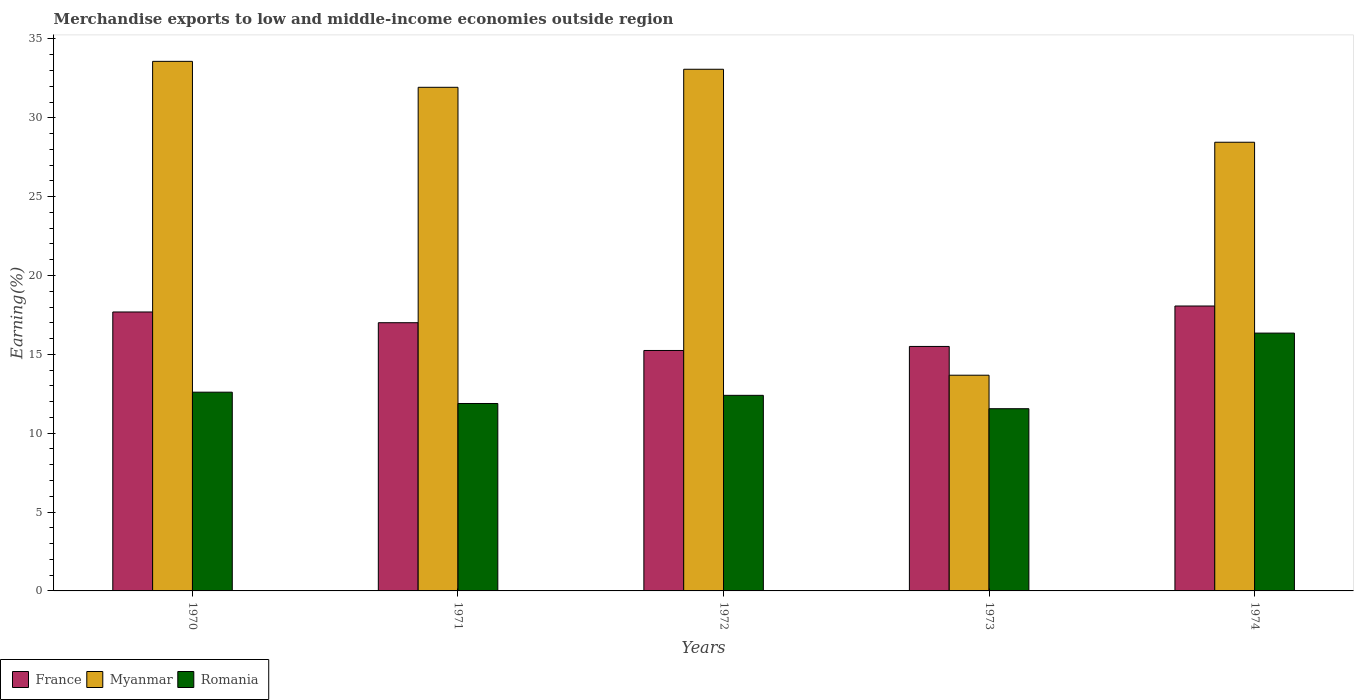How many different coloured bars are there?
Offer a very short reply. 3. How many groups of bars are there?
Provide a short and direct response. 5. Are the number of bars per tick equal to the number of legend labels?
Your answer should be very brief. Yes. How many bars are there on the 4th tick from the left?
Offer a terse response. 3. What is the percentage of amount earned from merchandise exports in France in 1973?
Give a very brief answer. 15.5. Across all years, what is the maximum percentage of amount earned from merchandise exports in Romania?
Your answer should be compact. 16.35. Across all years, what is the minimum percentage of amount earned from merchandise exports in Myanmar?
Provide a succinct answer. 13.68. In which year was the percentage of amount earned from merchandise exports in Myanmar maximum?
Ensure brevity in your answer.  1970. What is the total percentage of amount earned from merchandise exports in France in the graph?
Provide a short and direct response. 83.51. What is the difference between the percentage of amount earned from merchandise exports in France in 1972 and that in 1974?
Your response must be concise. -2.82. What is the difference between the percentage of amount earned from merchandise exports in Myanmar in 1970 and the percentage of amount earned from merchandise exports in Romania in 1971?
Offer a terse response. 21.7. What is the average percentage of amount earned from merchandise exports in Myanmar per year?
Make the answer very short. 28.15. In the year 1972, what is the difference between the percentage of amount earned from merchandise exports in France and percentage of amount earned from merchandise exports in Myanmar?
Your answer should be very brief. -17.83. In how many years, is the percentage of amount earned from merchandise exports in Romania greater than 2 %?
Your answer should be compact. 5. What is the ratio of the percentage of amount earned from merchandise exports in France in 1971 to that in 1972?
Make the answer very short. 1.12. Is the difference between the percentage of amount earned from merchandise exports in France in 1971 and 1972 greater than the difference between the percentage of amount earned from merchandise exports in Myanmar in 1971 and 1972?
Give a very brief answer. Yes. What is the difference between the highest and the second highest percentage of amount earned from merchandise exports in Romania?
Provide a short and direct response. 3.75. What is the difference between the highest and the lowest percentage of amount earned from merchandise exports in Romania?
Give a very brief answer. 4.79. Is the sum of the percentage of amount earned from merchandise exports in Romania in 1971 and 1973 greater than the maximum percentage of amount earned from merchandise exports in France across all years?
Ensure brevity in your answer.  Yes. What does the 3rd bar from the left in 1971 represents?
Offer a terse response. Romania. What does the 1st bar from the right in 1972 represents?
Your response must be concise. Romania. Is it the case that in every year, the sum of the percentage of amount earned from merchandise exports in France and percentage of amount earned from merchandise exports in Romania is greater than the percentage of amount earned from merchandise exports in Myanmar?
Provide a short and direct response. No. What is the difference between two consecutive major ticks on the Y-axis?
Give a very brief answer. 5. Are the values on the major ticks of Y-axis written in scientific E-notation?
Your answer should be very brief. No. How many legend labels are there?
Make the answer very short. 3. What is the title of the graph?
Your answer should be compact. Merchandise exports to low and middle-income economies outside region. Does "St. Lucia" appear as one of the legend labels in the graph?
Ensure brevity in your answer.  No. What is the label or title of the Y-axis?
Make the answer very short. Earning(%). What is the Earning(%) in France in 1970?
Your answer should be compact. 17.69. What is the Earning(%) of Myanmar in 1970?
Provide a succinct answer. 33.58. What is the Earning(%) in Romania in 1970?
Offer a terse response. 12.6. What is the Earning(%) in France in 1971?
Offer a terse response. 17.01. What is the Earning(%) of Myanmar in 1971?
Offer a very short reply. 31.94. What is the Earning(%) in Romania in 1971?
Your answer should be very brief. 11.89. What is the Earning(%) in France in 1972?
Keep it short and to the point. 15.25. What is the Earning(%) in Myanmar in 1972?
Provide a succinct answer. 33.08. What is the Earning(%) of Romania in 1972?
Ensure brevity in your answer.  12.4. What is the Earning(%) of France in 1973?
Provide a succinct answer. 15.5. What is the Earning(%) of Myanmar in 1973?
Keep it short and to the point. 13.68. What is the Earning(%) of Romania in 1973?
Your answer should be compact. 11.55. What is the Earning(%) in France in 1974?
Provide a succinct answer. 18.07. What is the Earning(%) in Myanmar in 1974?
Make the answer very short. 28.45. What is the Earning(%) in Romania in 1974?
Your answer should be compact. 16.35. Across all years, what is the maximum Earning(%) of France?
Give a very brief answer. 18.07. Across all years, what is the maximum Earning(%) in Myanmar?
Offer a terse response. 33.58. Across all years, what is the maximum Earning(%) of Romania?
Give a very brief answer. 16.35. Across all years, what is the minimum Earning(%) in France?
Provide a short and direct response. 15.25. Across all years, what is the minimum Earning(%) in Myanmar?
Keep it short and to the point. 13.68. Across all years, what is the minimum Earning(%) in Romania?
Offer a terse response. 11.55. What is the total Earning(%) in France in the graph?
Offer a terse response. 83.51. What is the total Earning(%) of Myanmar in the graph?
Keep it short and to the point. 140.73. What is the total Earning(%) in Romania in the graph?
Your answer should be very brief. 64.79. What is the difference between the Earning(%) in France in 1970 and that in 1971?
Your answer should be compact. 0.68. What is the difference between the Earning(%) of Myanmar in 1970 and that in 1971?
Your answer should be very brief. 1.65. What is the difference between the Earning(%) of Romania in 1970 and that in 1971?
Offer a very short reply. 0.72. What is the difference between the Earning(%) in France in 1970 and that in 1972?
Provide a succinct answer. 2.44. What is the difference between the Earning(%) of Myanmar in 1970 and that in 1972?
Your response must be concise. 0.5. What is the difference between the Earning(%) in Romania in 1970 and that in 1972?
Keep it short and to the point. 0.2. What is the difference between the Earning(%) of France in 1970 and that in 1973?
Your answer should be compact. 2.19. What is the difference between the Earning(%) in Myanmar in 1970 and that in 1973?
Keep it short and to the point. 19.9. What is the difference between the Earning(%) of Romania in 1970 and that in 1973?
Your answer should be very brief. 1.05. What is the difference between the Earning(%) in France in 1970 and that in 1974?
Your response must be concise. -0.38. What is the difference between the Earning(%) of Myanmar in 1970 and that in 1974?
Make the answer very short. 5.13. What is the difference between the Earning(%) in Romania in 1970 and that in 1974?
Your answer should be compact. -3.75. What is the difference between the Earning(%) of France in 1971 and that in 1972?
Your answer should be very brief. 1.76. What is the difference between the Earning(%) of Myanmar in 1971 and that in 1972?
Your answer should be very brief. -1.14. What is the difference between the Earning(%) of Romania in 1971 and that in 1972?
Your answer should be compact. -0.52. What is the difference between the Earning(%) of France in 1971 and that in 1973?
Keep it short and to the point. 1.5. What is the difference between the Earning(%) in Myanmar in 1971 and that in 1973?
Make the answer very short. 18.26. What is the difference between the Earning(%) in Romania in 1971 and that in 1973?
Provide a short and direct response. 0.33. What is the difference between the Earning(%) in France in 1971 and that in 1974?
Make the answer very short. -1.06. What is the difference between the Earning(%) in Myanmar in 1971 and that in 1974?
Your response must be concise. 3.48. What is the difference between the Earning(%) of Romania in 1971 and that in 1974?
Offer a very short reply. -4.46. What is the difference between the Earning(%) of France in 1972 and that in 1973?
Keep it short and to the point. -0.26. What is the difference between the Earning(%) of Myanmar in 1972 and that in 1973?
Give a very brief answer. 19.4. What is the difference between the Earning(%) of Romania in 1972 and that in 1973?
Provide a short and direct response. 0.85. What is the difference between the Earning(%) in France in 1972 and that in 1974?
Offer a terse response. -2.82. What is the difference between the Earning(%) in Myanmar in 1972 and that in 1974?
Provide a succinct answer. 4.63. What is the difference between the Earning(%) of Romania in 1972 and that in 1974?
Keep it short and to the point. -3.95. What is the difference between the Earning(%) in France in 1973 and that in 1974?
Offer a terse response. -2.56. What is the difference between the Earning(%) of Myanmar in 1973 and that in 1974?
Offer a very short reply. -14.77. What is the difference between the Earning(%) in Romania in 1973 and that in 1974?
Keep it short and to the point. -4.79. What is the difference between the Earning(%) of France in 1970 and the Earning(%) of Myanmar in 1971?
Offer a terse response. -14.25. What is the difference between the Earning(%) of France in 1970 and the Earning(%) of Romania in 1971?
Give a very brief answer. 5.8. What is the difference between the Earning(%) of Myanmar in 1970 and the Earning(%) of Romania in 1971?
Provide a short and direct response. 21.7. What is the difference between the Earning(%) of France in 1970 and the Earning(%) of Myanmar in 1972?
Make the answer very short. -15.39. What is the difference between the Earning(%) in France in 1970 and the Earning(%) in Romania in 1972?
Ensure brevity in your answer.  5.29. What is the difference between the Earning(%) of Myanmar in 1970 and the Earning(%) of Romania in 1972?
Offer a terse response. 21.18. What is the difference between the Earning(%) of France in 1970 and the Earning(%) of Myanmar in 1973?
Give a very brief answer. 4.01. What is the difference between the Earning(%) of France in 1970 and the Earning(%) of Romania in 1973?
Ensure brevity in your answer.  6.13. What is the difference between the Earning(%) of Myanmar in 1970 and the Earning(%) of Romania in 1973?
Provide a short and direct response. 22.03. What is the difference between the Earning(%) in France in 1970 and the Earning(%) in Myanmar in 1974?
Your answer should be compact. -10.76. What is the difference between the Earning(%) of France in 1970 and the Earning(%) of Romania in 1974?
Ensure brevity in your answer.  1.34. What is the difference between the Earning(%) in Myanmar in 1970 and the Earning(%) in Romania in 1974?
Your response must be concise. 17.23. What is the difference between the Earning(%) of France in 1971 and the Earning(%) of Myanmar in 1972?
Ensure brevity in your answer.  -16.07. What is the difference between the Earning(%) of France in 1971 and the Earning(%) of Romania in 1972?
Offer a very short reply. 4.61. What is the difference between the Earning(%) in Myanmar in 1971 and the Earning(%) in Romania in 1972?
Give a very brief answer. 19.53. What is the difference between the Earning(%) of France in 1971 and the Earning(%) of Myanmar in 1973?
Provide a succinct answer. 3.33. What is the difference between the Earning(%) of France in 1971 and the Earning(%) of Romania in 1973?
Provide a succinct answer. 5.45. What is the difference between the Earning(%) in Myanmar in 1971 and the Earning(%) in Romania in 1973?
Provide a short and direct response. 20.38. What is the difference between the Earning(%) in France in 1971 and the Earning(%) in Myanmar in 1974?
Provide a succinct answer. -11.44. What is the difference between the Earning(%) of France in 1971 and the Earning(%) of Romania in 1974?
Keep it short and to the point. 0.66. What is the difference between the Earning(%) in Myanmar in 1971 and the Earning(%) in Romania in 1974?
Your response must be concise. 15.59. What is the difference between the Earning(%) of France in 1972 and the Earning(%) of Myanmar in 1973?
Provide a succinct answer. 1.57. What is the difference between the Earning(%) of France in 1972 and the Earning(%) of Romania in 1973?
Make the answer very short. 3.69. What is the difference between the Earning(%) of Myanmar in 1972 and the Earning(%) of Romania in 1973?
Keep it short and to the point. 21.53. What is the difference between the Earning(%) in France in 1972 and the Earning(%) in Myanmar in 1974?
Offer a terse response. -13.2. What is the difference between the Earning(%) in France in 1972 and the Earning(%) in Romania in 1974?
Offer a very short reply. -1.1. What is the difference between the Earning(%) of Myanmar in 1972 and the Earning(%) of Romania in 1974?
Offer a terse response. 16.73. What is the difference between the Earning(%) of France in 1973 and the Earning(%) of Myanmar in 1974?
Provide a succinct answer. -12.95. What is the difference between the Earning(%) of France in 1973 and the Earning(%) of Romania in 1974?
Provide a short and direct response. -0.85. What is the difference between the Earning(%) of Myanmar in 1973 and the Earning(%) of Romania in 1974?
Provide a short and direct response. -2.67. What is the average Earning(%) of France per year?
Provide a succinct answer. 16.7. What is the average Earning(%) of Myanmar per year?
Your response must be concise. 28.15. What is the average Earning(%) of Romania per year?
Ensure brevity in your answer.  12.96. In the year 1970, what is the difference between the Earning(%) in France and Earning(%) in Myanmar?
Ensure brevity in your answer.  -15.89. In the year 1970, what is the difference between the Earning(%) of France and Earning(%) of Romania?
Provide a short and direct response. 5.09. In the year 1970, what is the difference between the Earning(%) of Myanmar and Earning(%) of Romania?
Make the answer very short. 20.98. In the year 1971, what is the difference between the Earning(%) of France and Earning(%) of Myanmar?
Your answer should be very brief. -14.93. In the year 1971, what is the difference between the Earning(%) in France and Earning(%) in Romania?
Your response must be concise. 5.12. In the year 1971, what is the difference between the Earning(%) in Myanmar and Earning(%) in Romania?
Your answer should be very brief. 20.05. In the year 1972, what is the difference between the Earning(%) of France and Earning(%) of Myanmar?
Your answer should be compact. -17.83. In the year 1972, what is the difference between the Earning(%) of France and Earning(%) of Romania?
Ensure brevity in your answer.  2.85. In the year 1972, what is the difference between the Earning(%) in Myanmar and Earning(%) in Romania?
Ensure brevity in your answer.  20.68. In the year 1973, what is the difference between the Earning(%) of France and Earning(%) of Myanmar?
Offer a very short reply. 1.82. In the year 1973, what is the difference between the Earning(%) of France and Earning(%) of Romania?
Ensure brevity in your answer.  3.95. In the year 1973, what is the difference between the Earning(%) in Myanmar and Earning(%) in Romania?
Your answer should be compact. 2.12. In the year 1974, what is the difference between the Earning(%) of France and Earning(%) of Myanmar?
Your response must be concise. -10.38. In the year 1974, what is the difference between the Earning(%) in France and Earning(%) in Romania?
Make the answer very short. 1.72. In the year 1974, what is the difference between the Earning(%) of Myanmar and Earning(%) of Romania?
Your answer should be compact. 12.1. What is the ratio of the Earning(%) of Myanmar in 1970 to that in 1971?
Your answer should be compact. 1.05. What is the ratio of the Earning(%) of Romania in 1970 to that in 1971?
Give a very brief answer. 1.06. What is the ratio of the Earning(%) in France in 1970 to that in 1972?
Your answer should be compact. 1.16. What is the ratio of the Earning(%) in Myanmar in 1970 to that in 1972?
Keep it short and to the point. 1.02. What is the ratio of the Earning(%) in Romania in 1970 to that in 1972?
Offer a terse response. 1.02. What is the ratio of the Earning(%) in France in 1970 to that in 1973?
Offer a terse response. 1.14. What is the ratio of the Earning(%) in Myanmar in 1970 to that in 1973?
Your response must be concise. 2.45. What is the ratio of the Earning(%) in Romania in 1970 to that in 1973?
Give a very brief answer. 1.09. What is the ratio of the Earning(%) in Myanmar in 1970 to that in 1974?
Ensure brevity in your answer.  1.18. What is the ratio of the Earning(%) of Romania in 1970 to that in 1974?
Keep it short and to the point. 0.77. What is the ratio of the Earning(%) of France in 1971 to that in 1972?
Your answer should be very brief. 1.12. What is the ratio of the Earning(%) of Myanmar in 1971 to that in 1972?
Offer a very short reply. 0.97. What is the ratio of the Earning(%) in Romania in 1971 to that in 1972?
Ensure brevity in your answer.  0.96. What is the ratio of the Earning(%) of France in 1971 to that in 1973?
Your answer should be compact. 1.1. What is the ratio of the Earning(%) of Myanmar in 1971 to that in 1973?
Make the answer very short. 2.33. What is the ratio of the Earning(%) in Romania in 1971 to that in 1973?
Offer a very short reply. 1.03. What is the ratio of the Earning(%) in France in 1971 to that in 1974?
Provide a short and direct response. 0.94. What is the ratio of the Earning(%) of Myanmar in 1971 to that in 1974?
Your response must be concise. 1.12. What is the ratio of the Earning(%) of Romania in 1971 to that in 1974?
Ensure brevity in your answer.  0.73. What is the ratio of the Earning(%) of France in 1972 to that in 1973?
Your answer should be compact. 0.98. What is the ratio of the Earning(%) in Myanmar in 1972 to that in 1973?
Offer a very short reply. 2.42. What is the ratio of the Earning(%) in Romania in 1972 to that in 1973?
Ensure brevity in your answer.  1.07. What is the ratio of the Earning(%) of France in 1972 to that in 1974?
Keep it short and to the point. 0.84. What is the ratio of the Earning(%) in Myanmar in 1972 to that in 1974?
Give a very brief answer. 1.16. What is the ratio of the Earning(%) of Romania in 1972 to that in 1974?
Ensure brevity in your answer.  0.76. What is the ratio of the Earning(%) in France in 1973 to that in 1974?
Provide a succinct answer. 0.86. What is the ratio of the Earning(%) of Myanmar in 1973 to that in 1974?
Ensure brevity in your answer.  0.48. What is the ratio of the Earning(%) of Romania in 1973 to that in 1974?
Give a very brief answer. 0.71. What is the difference between the highest and the second highest Earning(%) in France?
Ensure brevity in your answer.  0.38. What is the difference between the highest and the second highest Earning(%) of Myanmar?
Your answer should be compact. 0.5. What is the difference between the highest and the second highest Earning(%) in Romania?
Offer a terse response. 3.75. What is the difference between the highest and the lowest Earning(%) of France?
Give a very brief answer. 2.82. What is the difference between the highest and the lowest Earning(%) in Myanmar?
Your response must be concise. 19.9. What is the difference between the highest and the lowest Earning(%) in Romania?
Give a very brief answer. 4.79. 